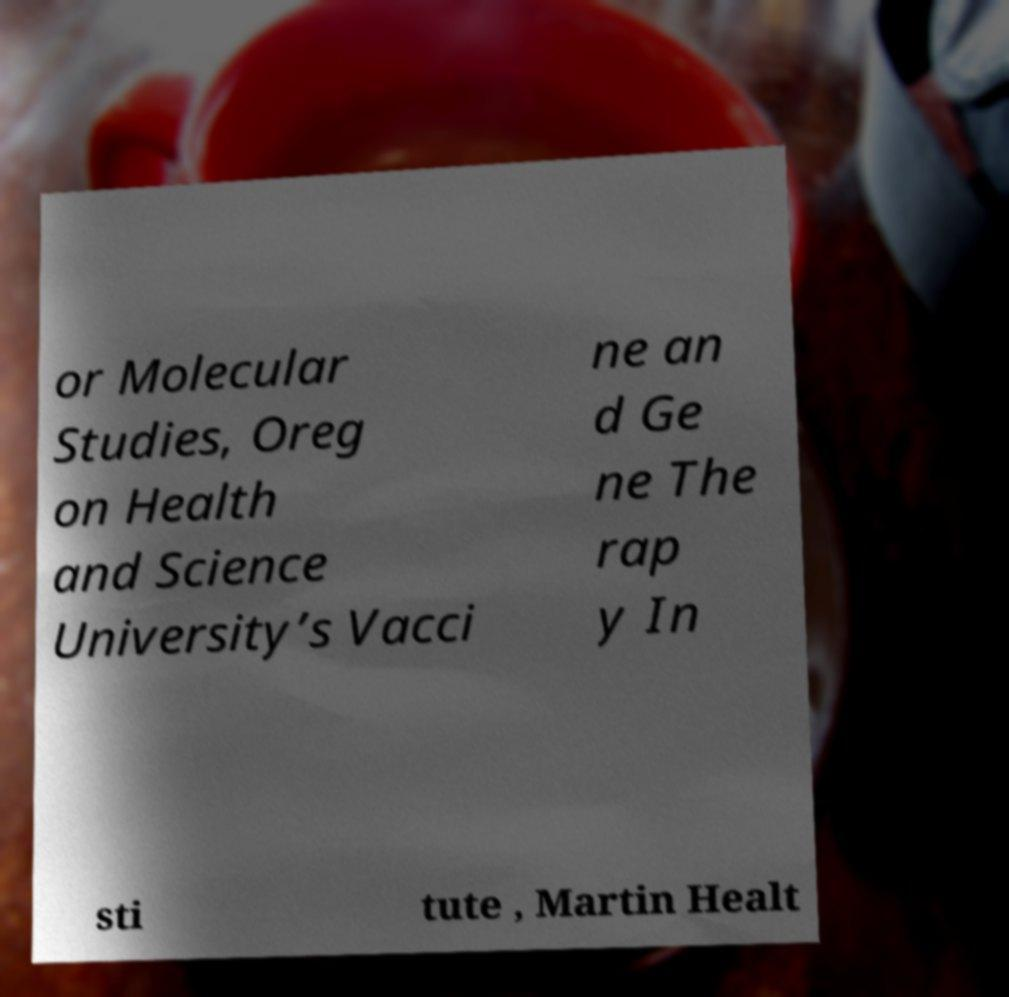I need the written content from this picture converted into text. Can you do that? or Molecular Studies, Oreg on Health and Science University’s Vacci ne an d Ge ne The rap y In sti tute , Martin Healt 